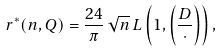Convert formula to latex. <formula><loc_0><loc_0><loc_500><loc_500>r ^ { * } ( n , Q ) = \frac { 2 4 } { \pi } \, \sqrt { n } \, L \left ( 1 , \left ( \frac { D } { \cdot } \right ) \right ) ,</formula> 